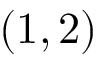Convert formula to latex. <formula><loc_0><loc_0><loc_500><loc_500>( 1 , 2 )</formula> 